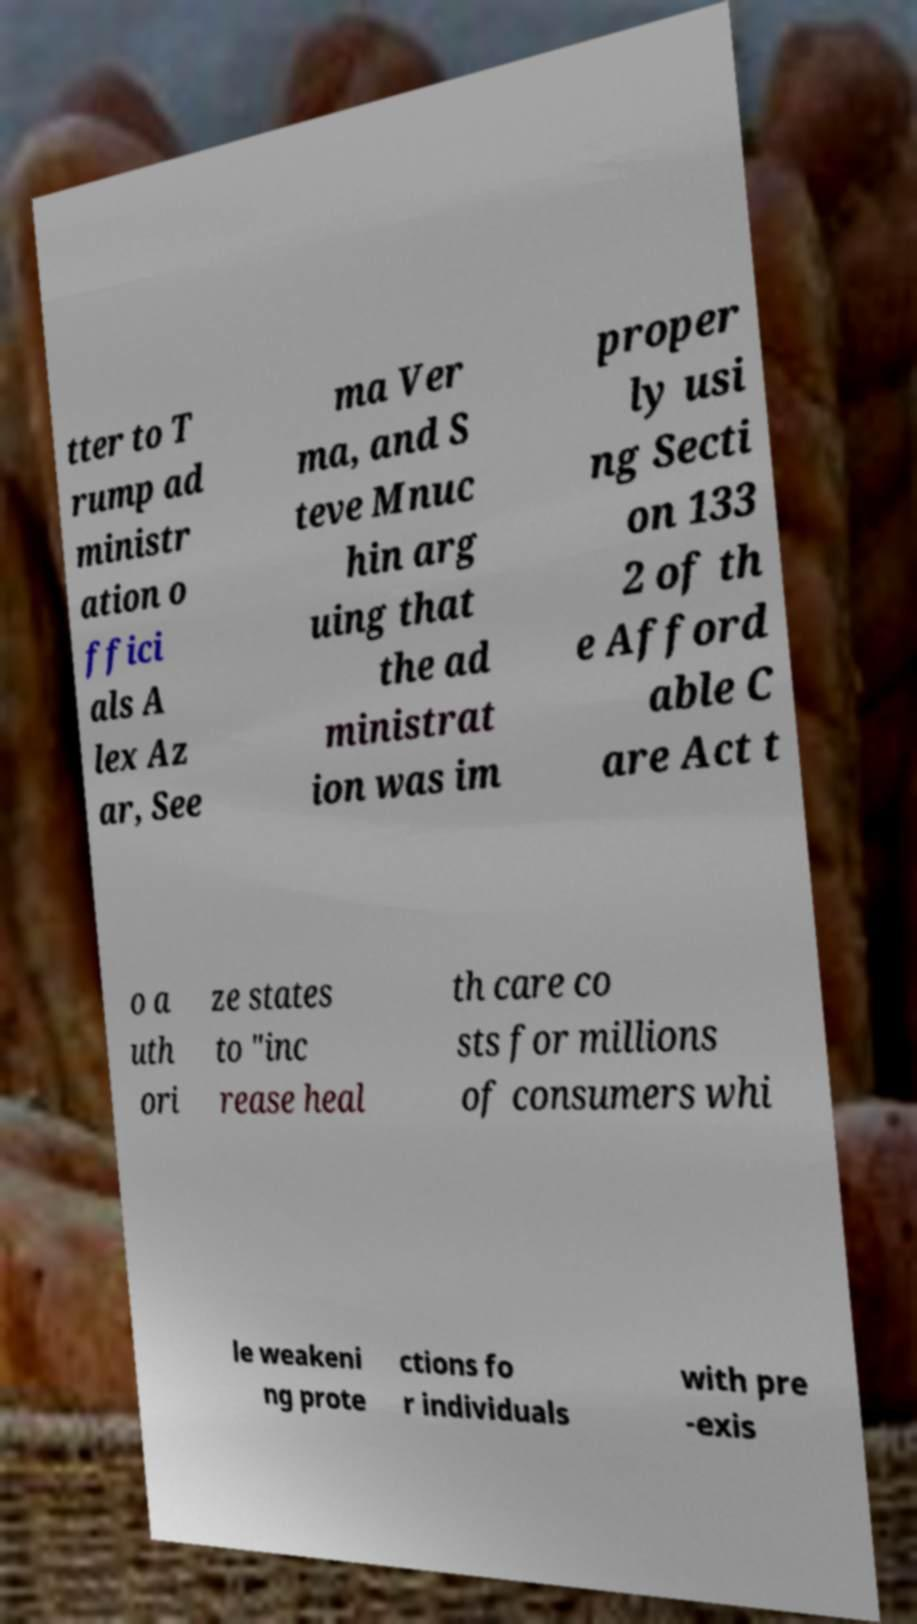Could you extract and type out the text from this image? tter to T rump ad ministr ation o ffici als A lex Az ar, See ma Ver ma, and S teve Mnuc hin arg uing that the ad ministrat ion was im proper ly usi ng Secti on 133 2 of th e Afford able C are Act t o a uth ori ze states to "inc rease heal th care co sts for millions of consumers whi le weakeni ng prote ctions fo r individuals with pre -exis 